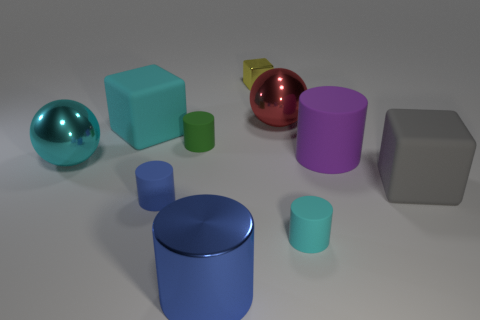Which object stands out the most due to its color? The sphere with its lustrous, magenta hue immediately draws the eye, setting it apart from the cooler and more subdued colors in the rest of the scene. Can you describe the texture of that magenta sphere? The magenta sphere exhibits a highly reflective surface, giving it an almost metallic sheen that accentuates its vivid color and adds depth to its appearance. 